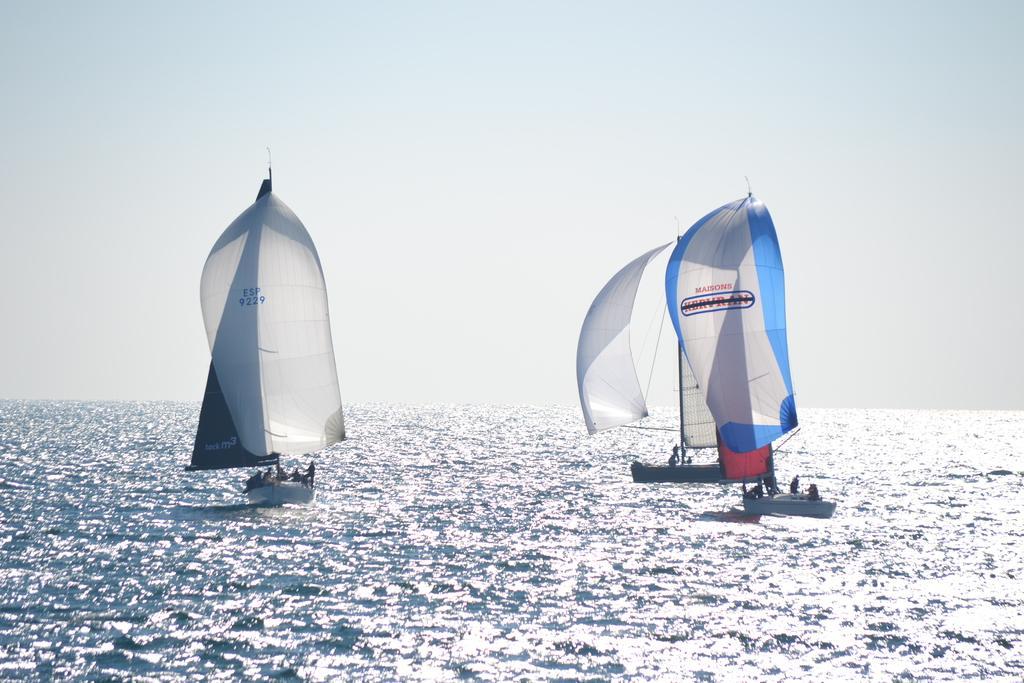In one or two sentences, can you explain what this image depicts? In this picture there are boats on the water and there are group of people on the boats. At the top there is sky. At the bottom there is water. 